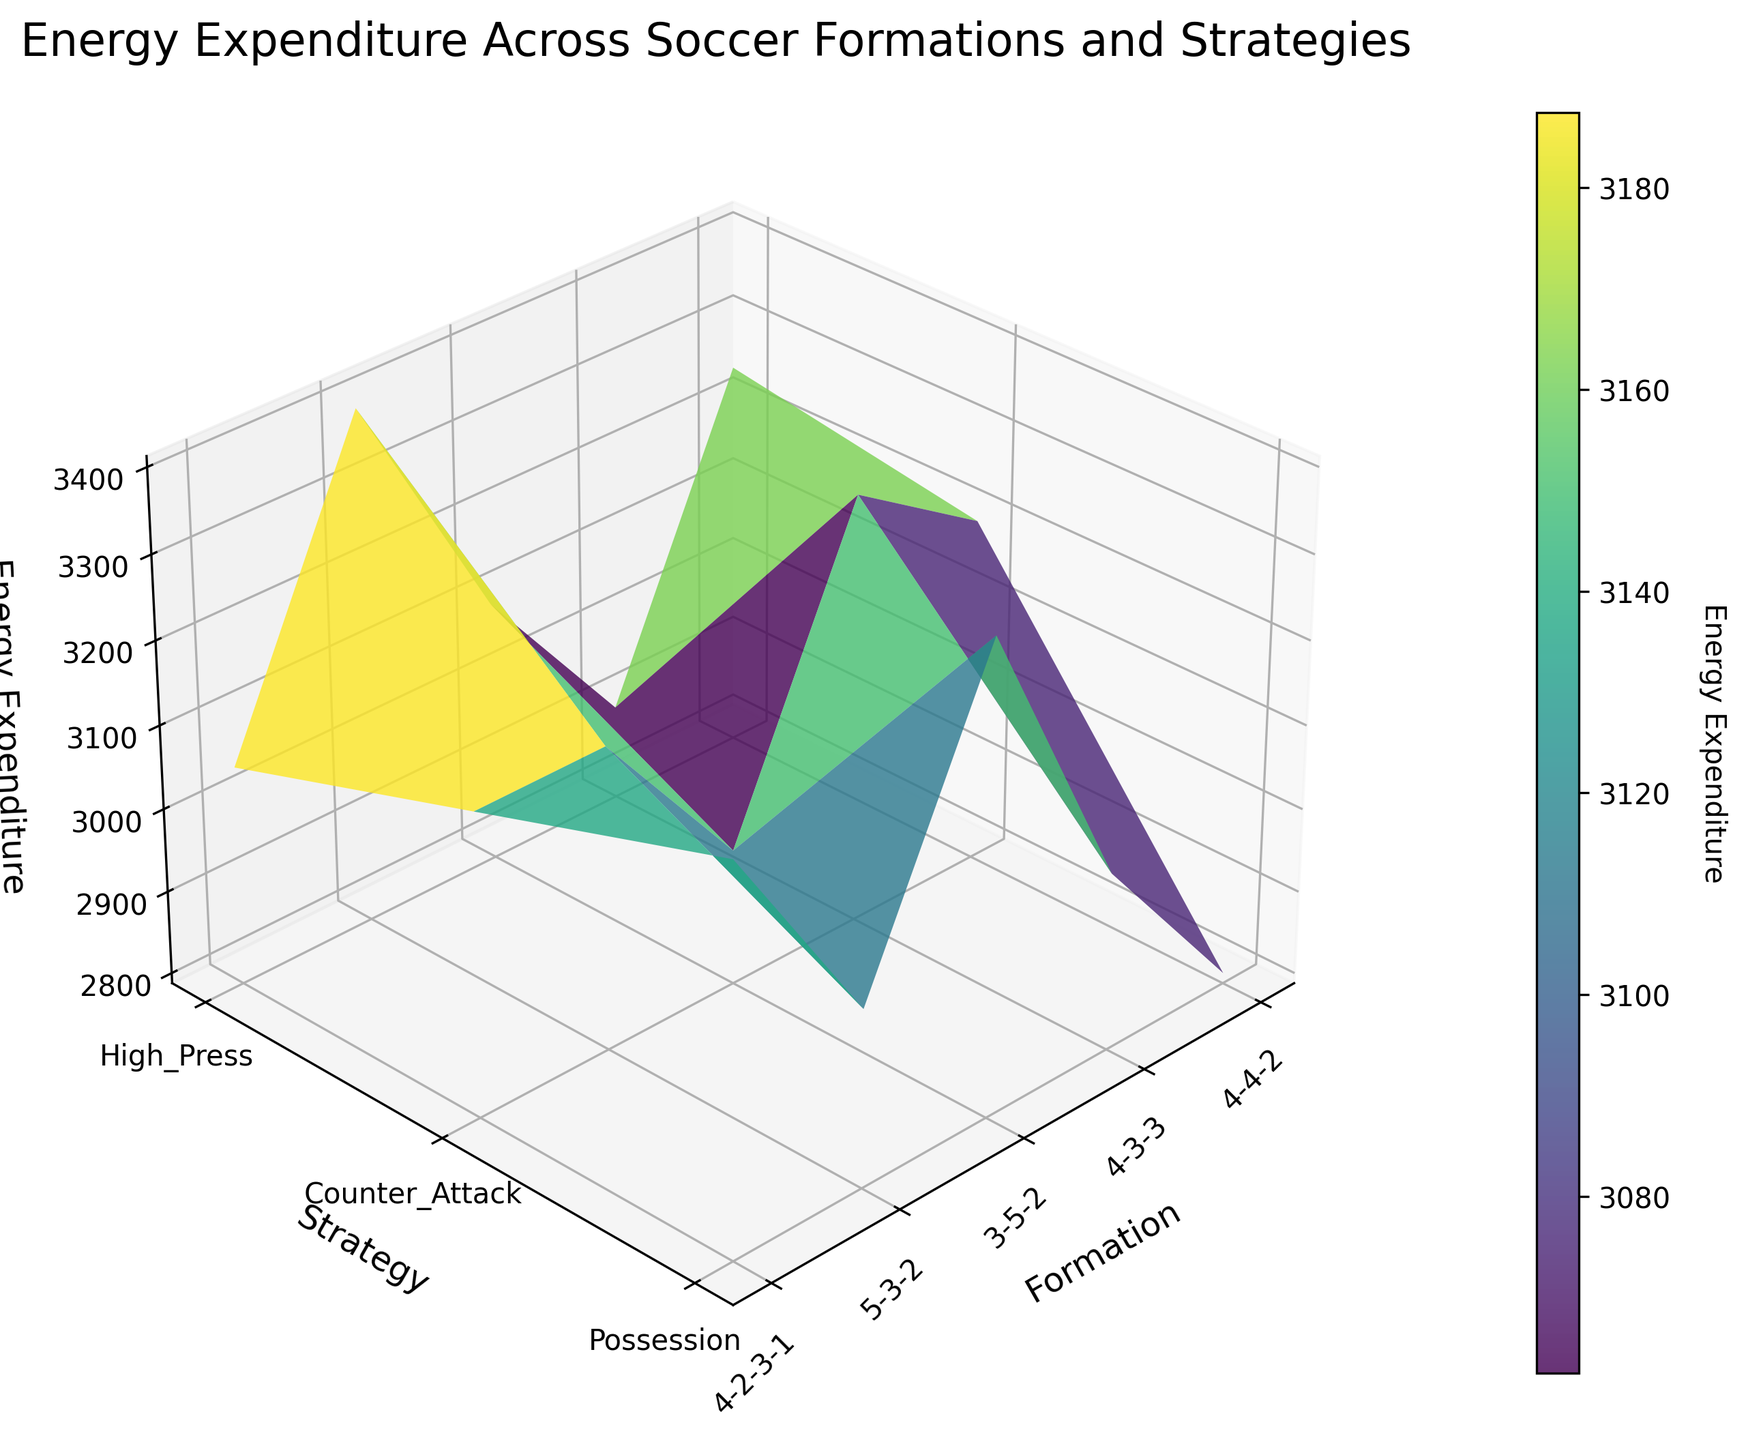What is the title of the figure? The title is located at the top of the 3D surface plot and reads "Energy Expenditure Across Soccer Formations and Strategies"
Answer: Energy Expenditure Across Soccer Formations and Strategies Which formations are compared in the figure? The formations are denoted on the x-axis and include the following options: 4-4-2, 4-3-3, 3-5-2, 5-3-2, and 4-2-3-1
Answer: 4-4-2, 4-3-3, 3-5-2, 5-3-2, 4-2-3-1 What tactical strategies are analyzed in the figure? The strategies are indicated on the y-axis and are labeled as High_Press, Counter_Attack, and Possession
Answer: High_Press, Counter_Attack, Possession Which formation and strategy combination has the highest energy expenditure? To find the combination with the highest energy expenditure, identify the highest peak on the 3D surface plot. It is the 4-3-3 formation with the High_Press strategy.
Answer: 4-3-3, High_Press Which strategy has the lowest energy expenditure for the 5-3-2 formation? Locate the energy expenditure values associated with the 5-3-2 formation on the x-axis and compare the different strategies. The lowest value is 2800 for the Counter_Attack strategy.
Answer: Counter_Attack What is the energy expenditure difference between the 4-2-3-1 and 3-5-2 formations under the Possession strategy? Identify the energy expenditure for the 4-2-3-1 and 3-5-2 formations with the Possession strategy: 3250 and 3150, respectively. Calculate the difference: 3250 - 3150 = 100
Answer: 100 How does the energy expenditure of the High_Press strategy compare to the Counter_Attack strategy for the 4-3-3 formation? Identify the energy expenditure for the 4-3-3 formation with the High_Press strategy (3400) and the Counter_Attack strategy (3050). The High_Press strategy requires more energy.
Answer: The High_Press strategy requires more energy What is the overall trend in energy expenditure for the High_Press strategy across different formations? Observe the surface plot along the High_Press strategy line. The energy expenditure varies among formations but generally shows higher values compared to other strategies.
Answer: Generally higher values Which formation and strategy combination has the median energy expenditure value? List all energy expenditure values and identify the median value: (3250, 2900, 3100, 3400, 3050, 3200, 3300, 2950, 3150, 3150, 2800, 3000, 3350, 3000, 3250). The median is 3150, which occurs at 3-5-2 High_Press, and 5-3-2 High_Press.
Answer: 3-5-2 High_Press and 5-3-2 High_Press 